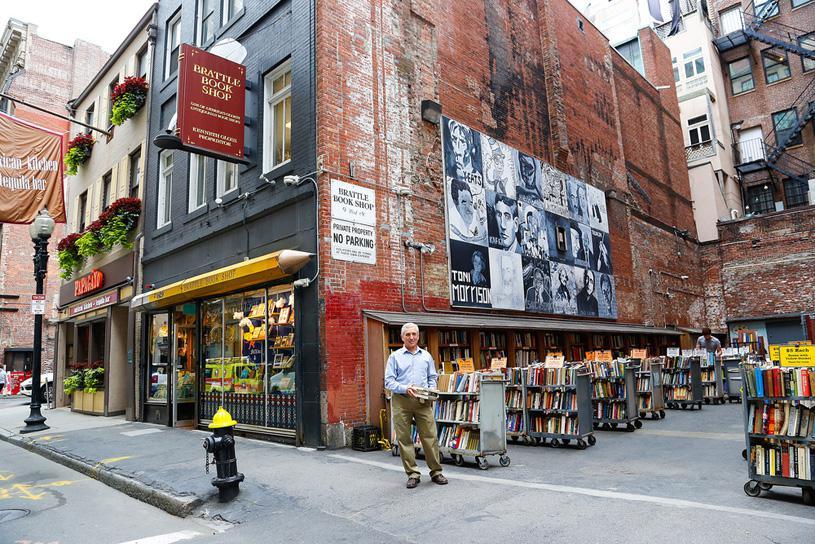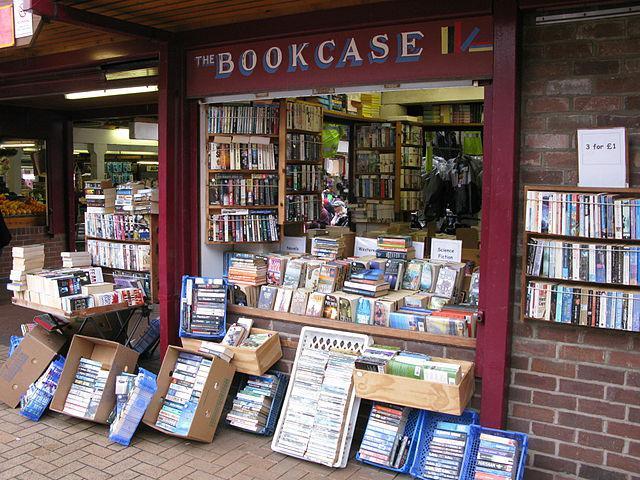The first image is the image on the left, the second image is the image on the right. Assess this claim about the two images: "A person is sitting on the ground in front of a store in the right image.". Correct or not? Answer yes or no. No. The first image is the image on the left, the second image is the image on the right. For the images displayed, is the sentence "No people are shown in front of the bookshop in the image on the right." factually correct? Answer yes or no. Yes. 